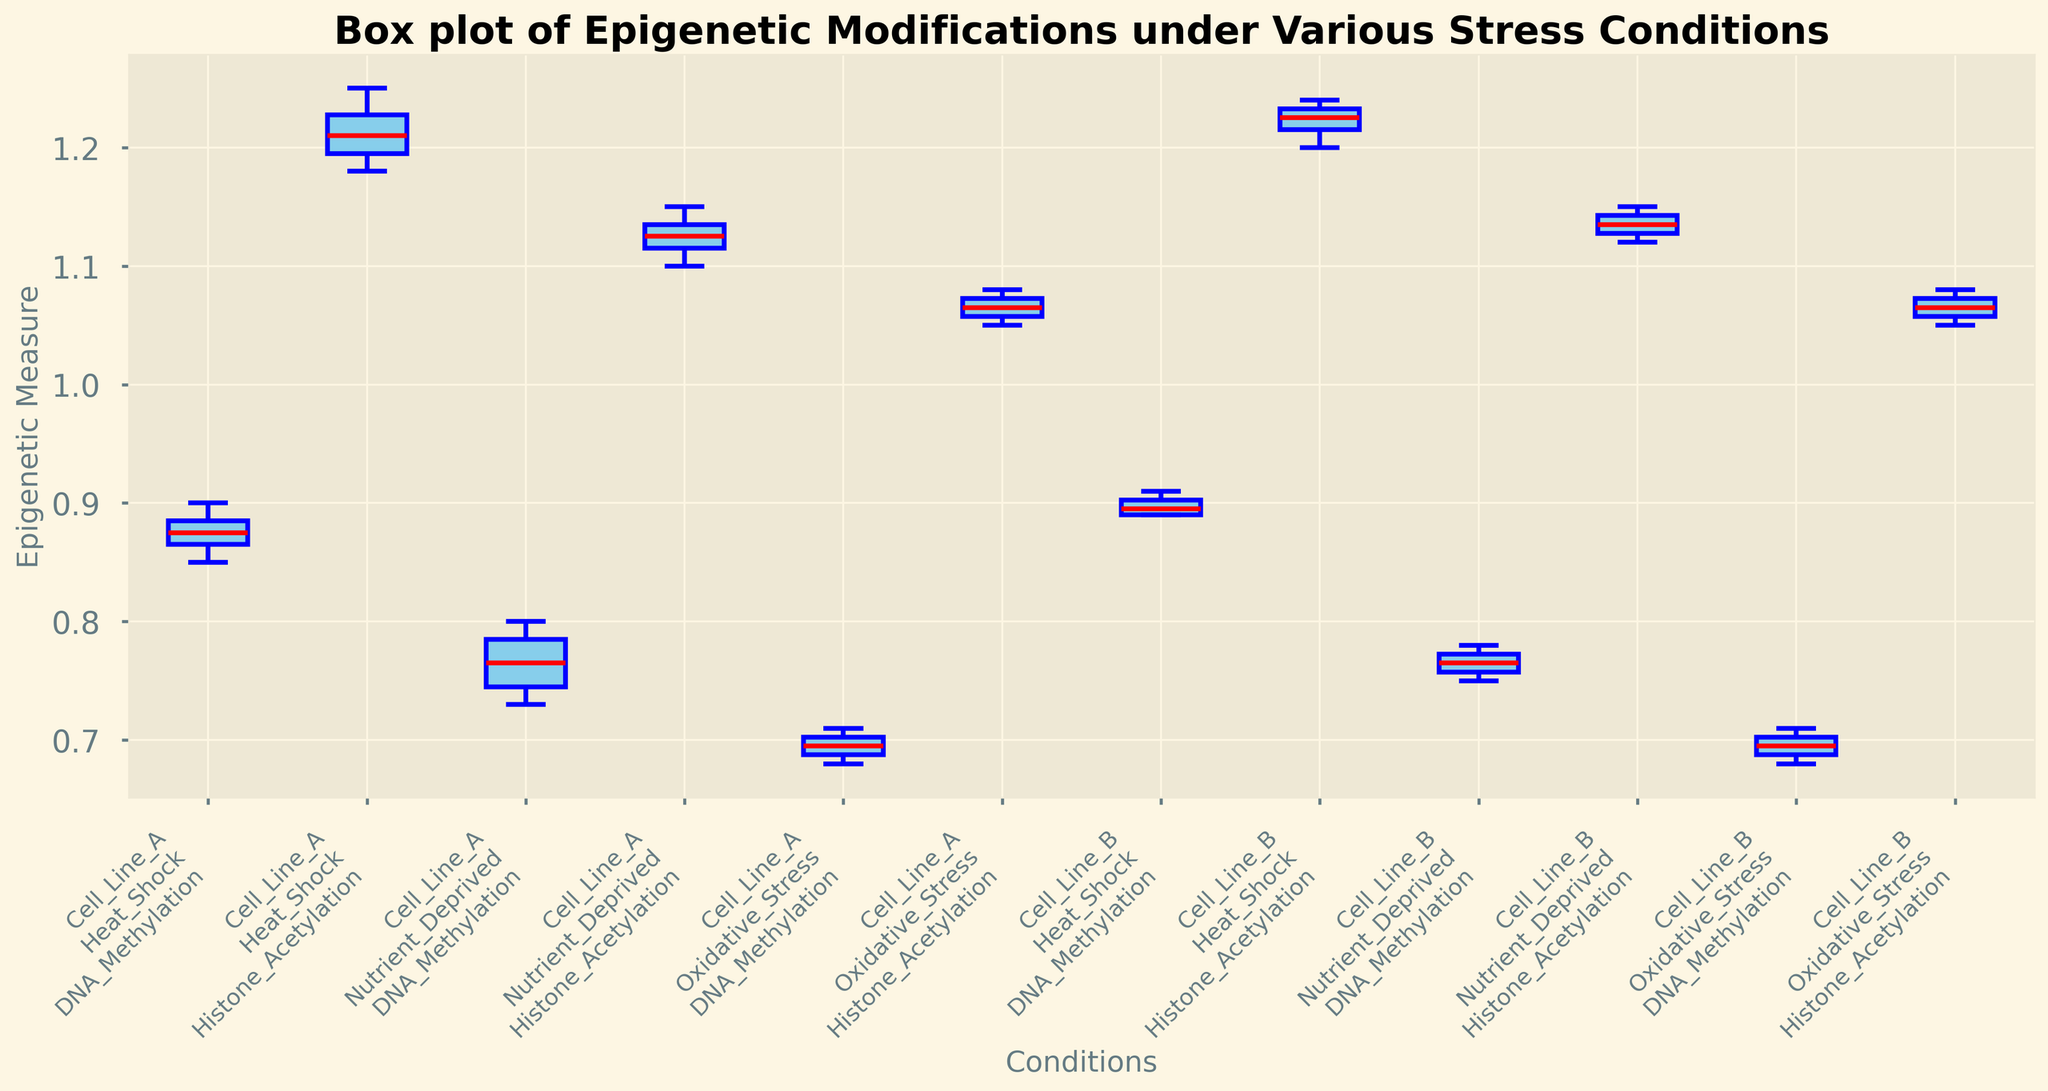What's the median value of DNA Methylation for Cell Line A under Nutrient Deprived conditions? To find the median, we need to arrange the DNA Methylation values for Cell Line A under Nutrient Deprived conditions in ascending order: 0.73, 0.75, 0.78, 0.80. The median is the average of the two middle values (0.75 and 0.78), which is (0.75 + 0.78) / 2 = 0.765.
Answer: 0.765 Which cell type and stress condition combination has the highest median value for Histone Acetylation? Compare the median values of Histone Acetylation across all combinations. For Cell Line A: Heat Shock (1.21), Nutrient Deprived (1.135), Oxidative Stress (1.065). For Cell Line B: Heat Shock (1.225), Nutrient Deprived (1.135), Oxidative Stress (1.065). The combination with the highest median value is Cell Line B under Heat Shock with a median value of 1.225.
Answer: Cell Line B under Heat Shock What's the interquartile range (IQR) of DNA Methylation values for Cell Line B under Heat_Shock conditions? The IQR is the difference between the third quartile (Q3) and the first quartile (Q1). For Cell Line B under Heat_Shock, the DNA Methylation values in ascending order are 0.89, 0.89, 0.90, 0.91. Q1 = 0.89, Q3 = 0.90. Thus, IQR = Q3 - Q1 = 0.90 - 0.89 = 0.01.
Answer: 0.01 Are the boxes for Histone Acetylation measurements under Oxidative Stress conditions for both cell lines visually distinct in terms of height? Compare the heights of the boxes representing Histone Acetylation under Oxidative Stress for both Cell Lines A and B. Both boxes are similar in height as they both have a small spread (values close together). This indicates low variability in the measurements.
Answer: No Which stress condition shows the greatest variability in DNA Methylation values for Cell Line A? The variability is indicated by the height of the box. Compare the heights of the boxes: Heat_Shock, Nutrient_Deprived, and Oxidative_Stress for Cell Line A. The box for Heat_Shock is taller, indicating greater variability.
Answer: Heat_Shock For Cell Line B, how does the median DNA Methylation value compare between Nutrient Deprived and Oxidative Stress conditions? Find the medians and compare them. For Nutrient_Deprived: Median = 0.76. For Oxidative_Stress: Median = 0.695. Nutrient Deprived has a higher median value than Oxidative Stress.
Answer: Nutrient Deprived > Oxidative Stress Which combination of Cell Type and Stress Condition for Histone Acetylation has the lowest maximum value? Compare the maximum values for Histone Acetylation across all combinations. Cell Line A: Heat Shock (1.25), Nutrient Deprived (1.15), Oxidative Stress (1.08). Cell Line B: Heat Shock (1.24), Nutrient Deprived (1.15), Oxidative Stress (1.08). The lowest maximum value is for Cell Lines A and B under Oxidative Stress, both having a maximum value of 1.08.
Answer: Cell Line A & B under Oxidative Stress 